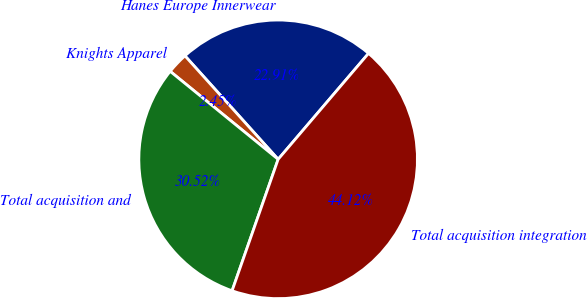Convert chart to OTSL. <chart><loc_0><loc_0><loc_500><loc_500><pie_chart><fcel>Hanes Europe Innerwear<fcel>Knights Apparel<fcel>Total acquisition and<fcel>Total acquisition integration<nl><fcel>22.91%<fcel>2.45%<fcel>30.52%<fcel>44.12%<nl></chart> 